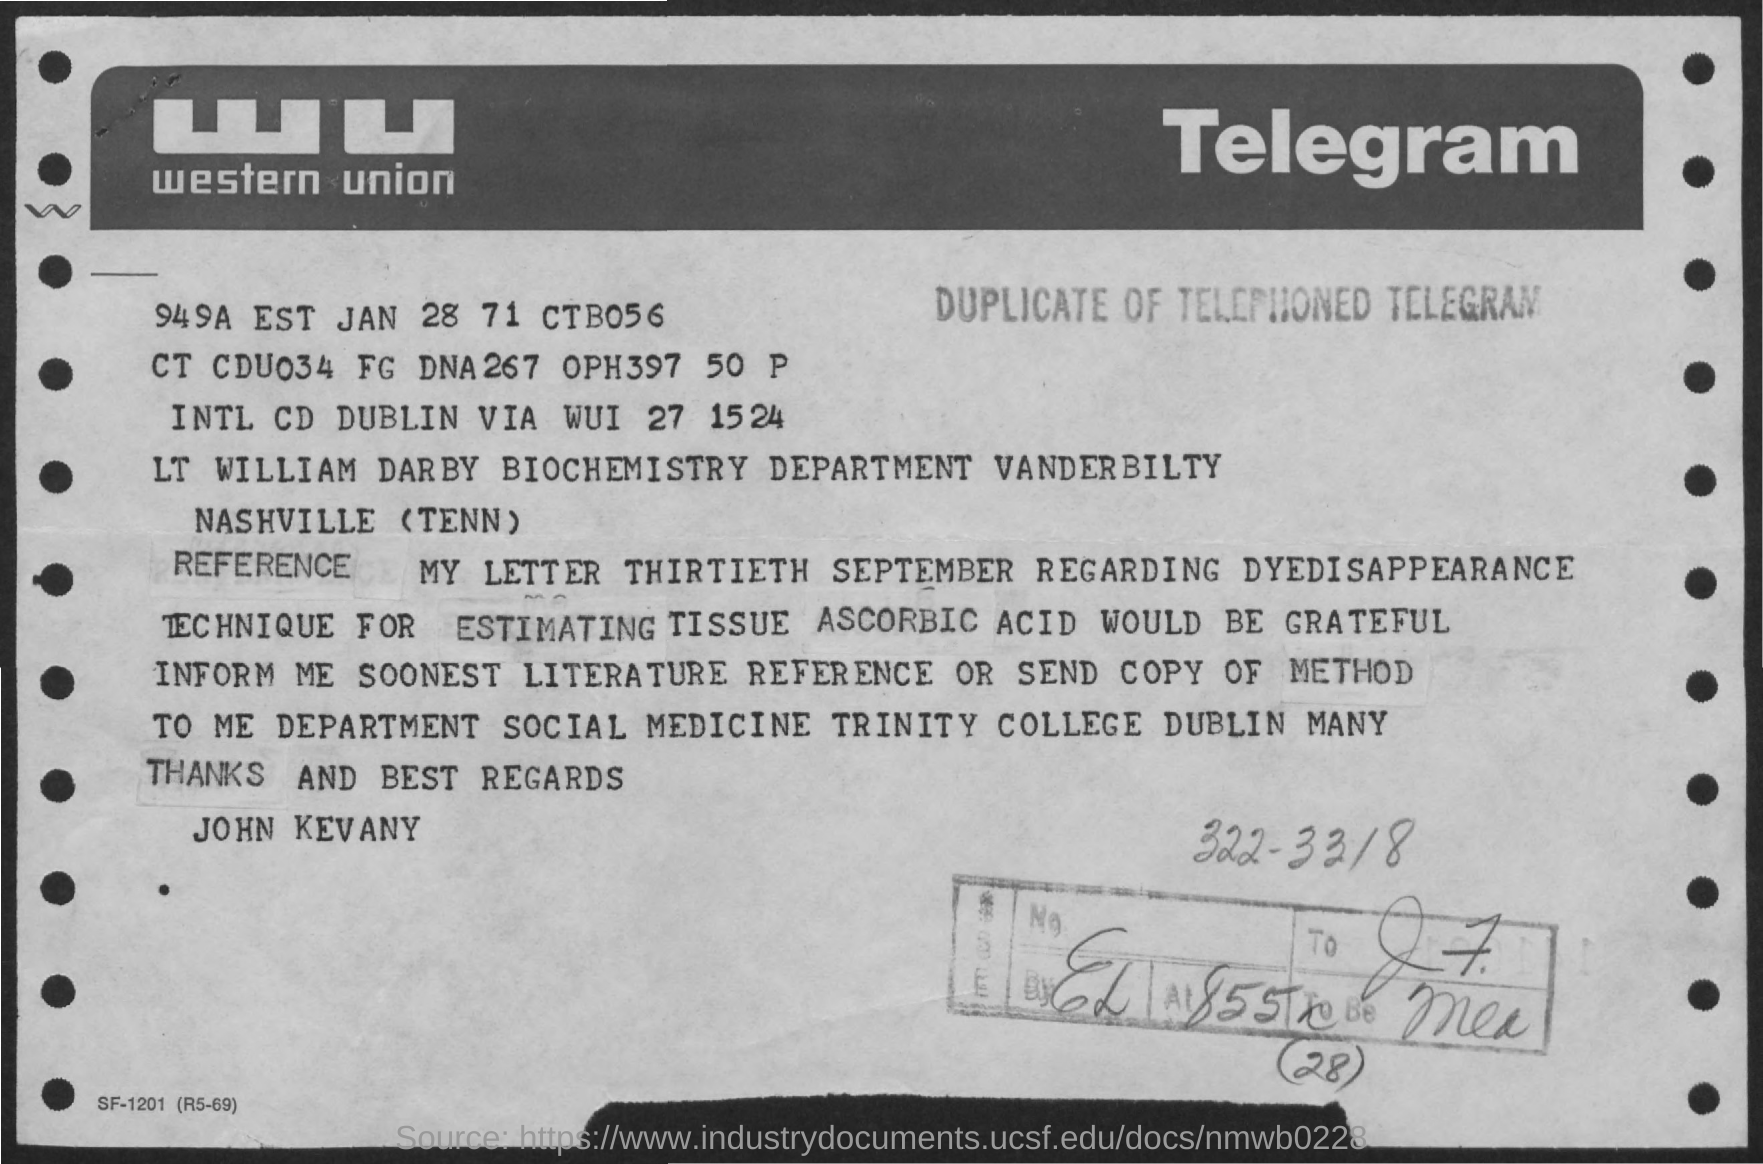What is the telegram company name?
Give a very brief answer. Western Union. Who is the sender?
Provide a succinct answer. John Kevany. 